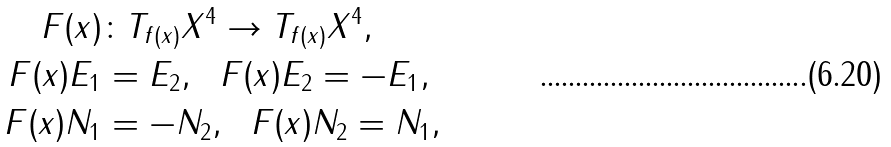<formula> <loc_0><loc_0><loc_500><loc_500>F ( x ) & \colon T _ { f ( x ) } X ^ { 4 } \to T _ { f ( x ) } X ^ { 4 } , \\ F ( x ) E _ { 1 } & = E _ { 2 } , \ \ F ( x ) E _ { 2 } = - E _ { 1 } , \\ F ( x ) N _ { 1 } & = - N _ { 2 } , \ \ F ( x ) N _ { 2 } = N _ { 1 } ,</formula> 